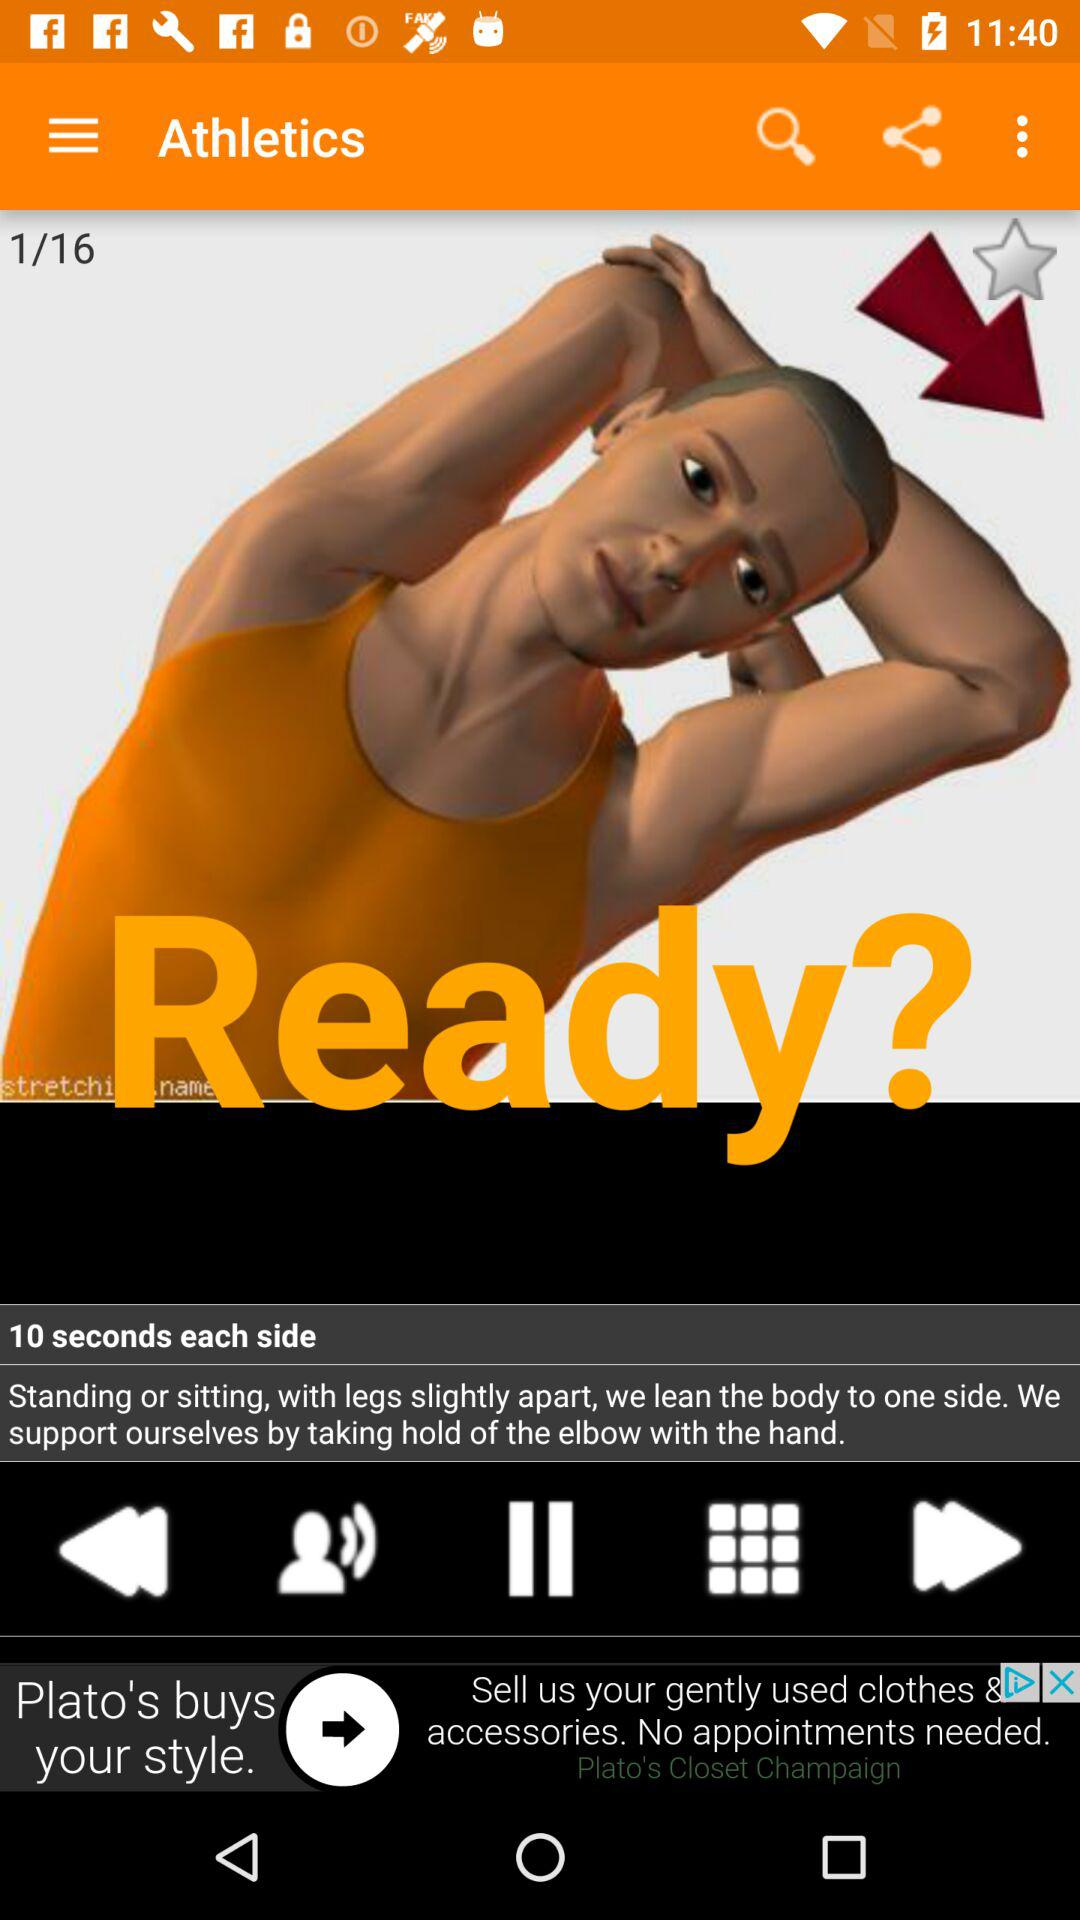What is the total number of slides? The total number of slides is 16. 